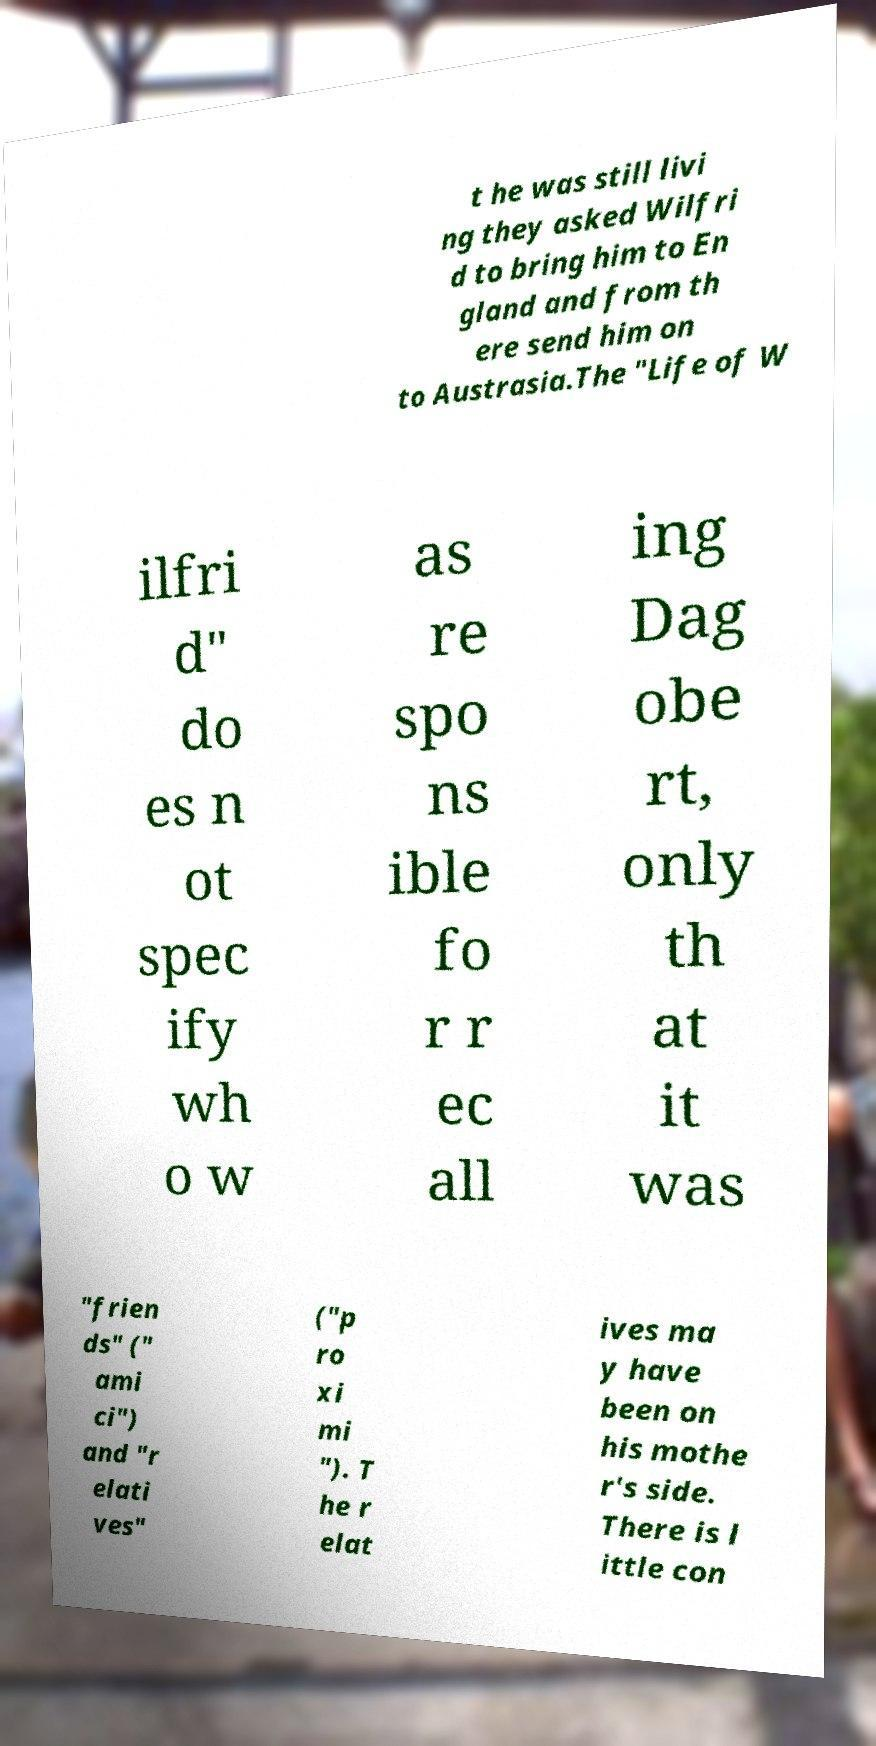Can you read and provide the text displayed in the image?This photo seems to have some interesting text. Can you extract and type it out for me? t he was still livi ng they asked Wilfri d to bring him to En gland and from th ere send him on to Austrasia.The "Life of W ilfri d" do es n ot spec ify wh o w as re spo ns ible fo r r ec all ing Dag obe rt, only th at it was "frien ds" (" ami ci") and "r elati ves" ("p ro xi mi "). T he r elat ives ma y have been on his mothe r's side. There is l ittle con 